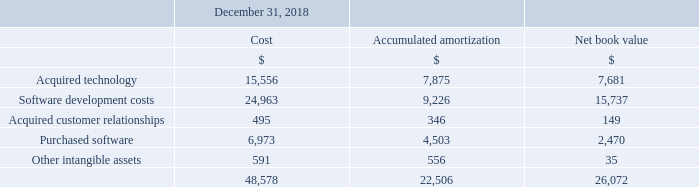Intangible Assets
Internal software development costs of $2,526 and $12,666 were capitalized during the years ended December 31, 2019 and 2018, respectively, and are classified within software development costs as an intangible asset. Amortization expense related to the capitalized internally developed software was $7,464 and $3,832 for the years ended December 31, 2019 and 2018, respectively, and is included in cost of revenues, sales and marketing and general and administrative expenses in the accompanying Consolidated Statements of Operations and Comprehensive Loss.
Expressed in US $000's except share and per share amounts
What financial items does intangible assets comprise of? Acquired technology, software development costs, acquired customer relationships, purchased software, other intangible assets. What information does the table show? Intangible assets. What is the cost of acquired technology as at December 31, 2018?
Answer scale should be: thousand. 15,556. How much is the 2019 software development costs excluding the internal software development costs of $12,666?
Answer scale should be: thousand. 24,963-12,666
Answer: 12297. What is the average amortization expense relating to the capitalized internally developed software for 2018 and 2019?
Answer scale should be: thousand. (7,464+3,832)/2
Answer: 5648. Between 2018 and 2019 year end, which year had a higher amount of intangible assets? 48,578>22,506
Answer: 2019. 